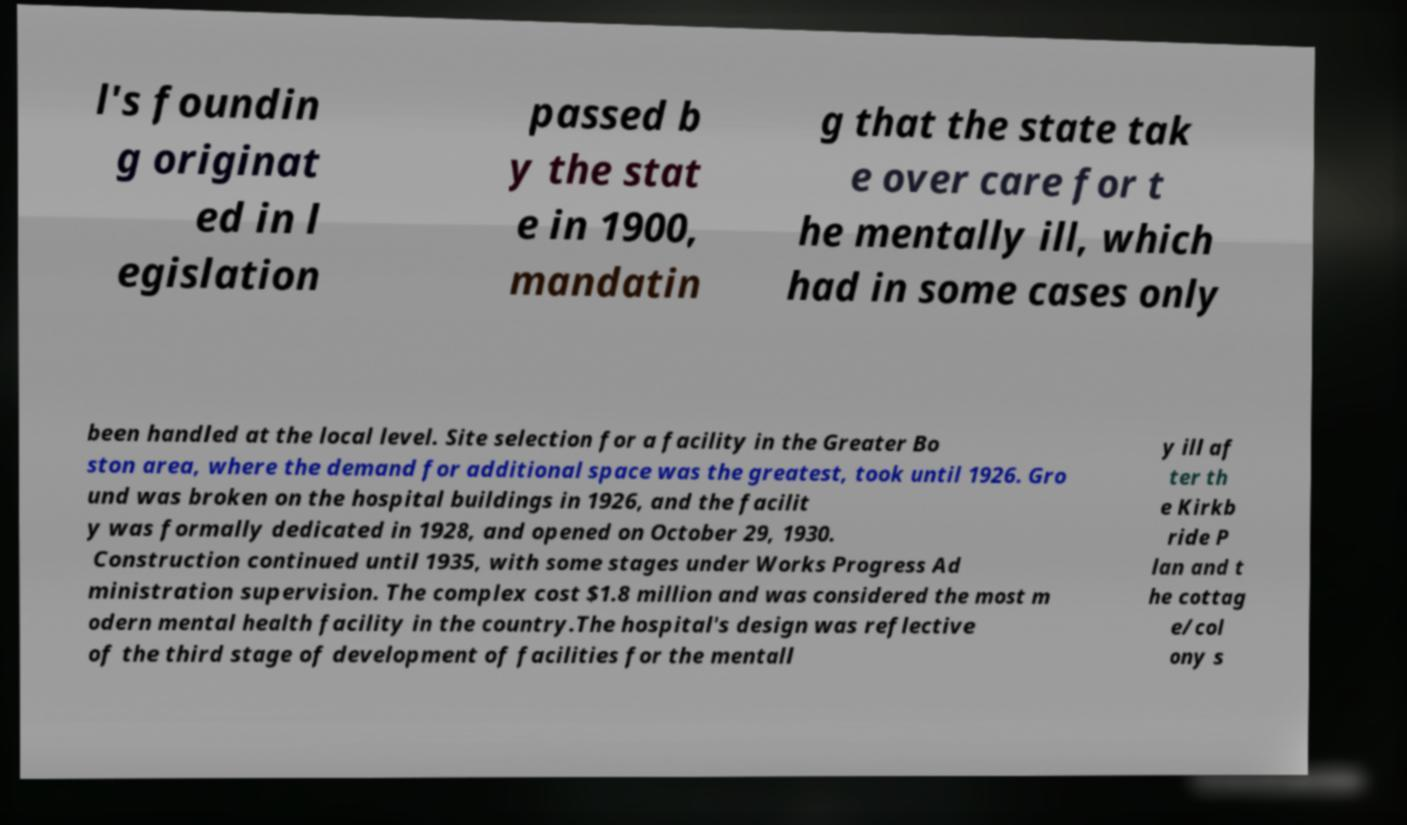Could you extract and type out the text from this image? l's foundin g originat ed in l egislation passed b y the stat e in 1900, mandatin g that the state tak e over care for t he mentally ill, which had in some cases only been handled at the local level. Site selection for a facility in the Greater Bo ston area, where the demand for additional space was the greatest, took until 1926. Gro und was broken on the hospital buildings in 1926, and the facilit y was formally dedicated in 1928, and opened on October 29, 1930. Construction continued until 1935, with some stages under Works Progress Ad ministration supervision. The complex cost $1.8 million and was considered the most m odern mental health facility in the country.The hospital's design was reflective of the third stage of development of facilities for the mentall y ill af ter th e Kirkb ride P lan and t he cottag e/col ony s 